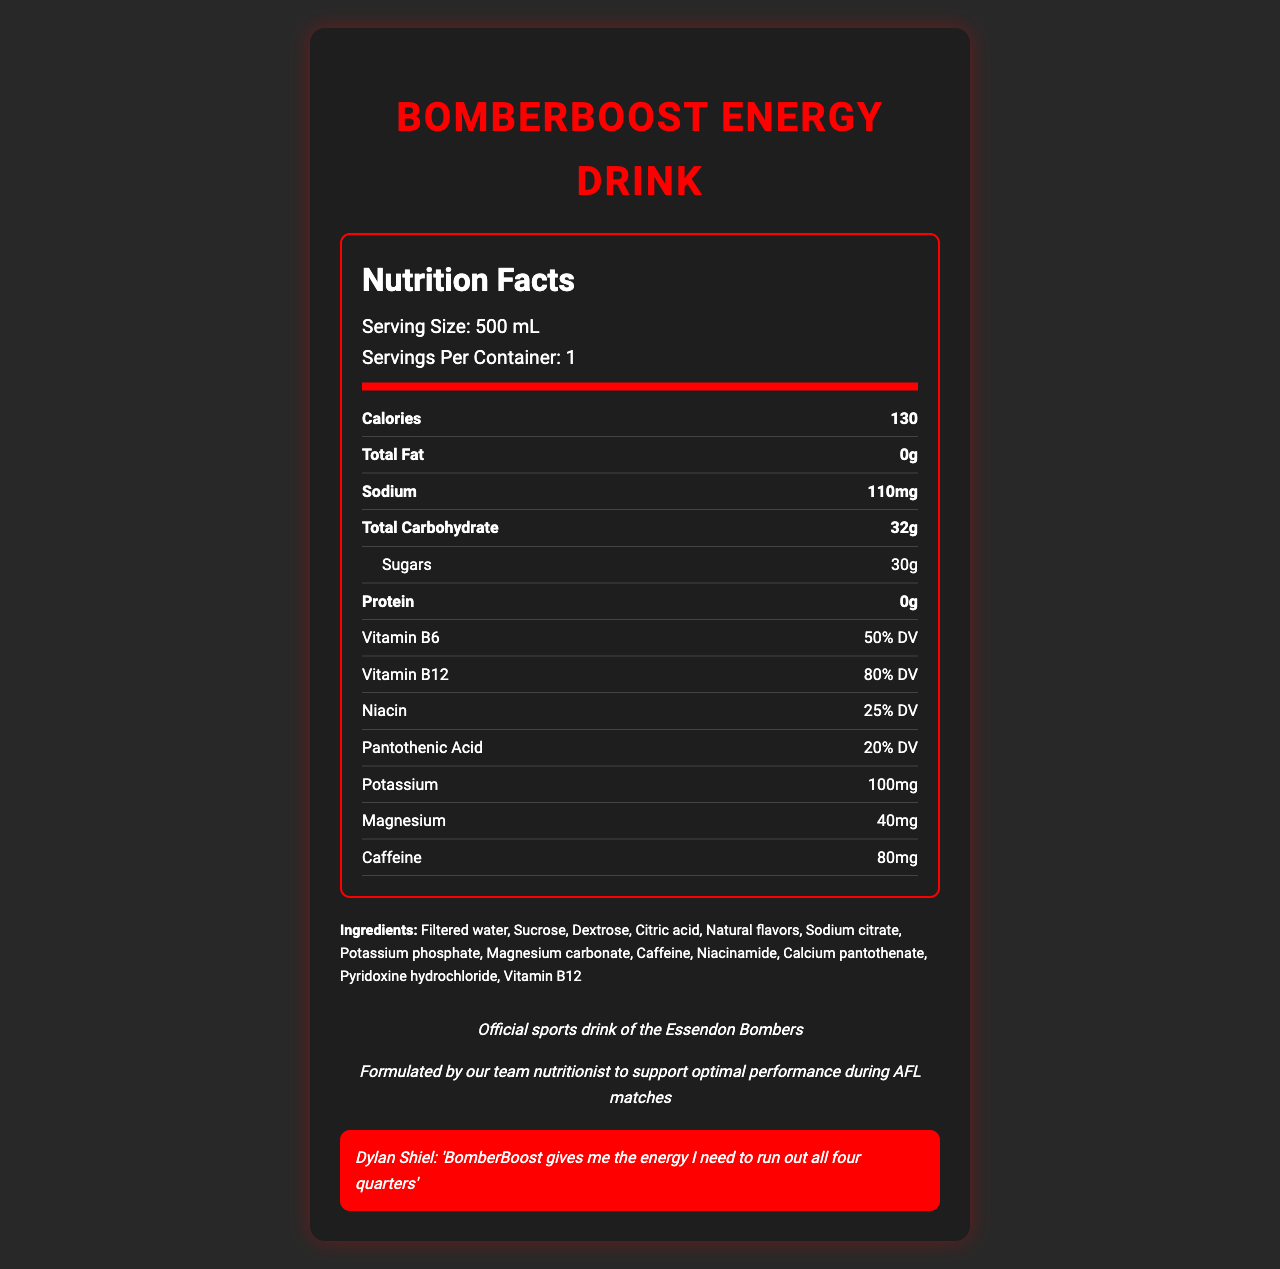what is the serving size of BomberBoost Energy Drink? The serving size is explicitly mentioned in the document under the nutrition facts.
Answer: 500 mL how many calories are in one serving of BomberBoost Energy Drink? The calories per serving are listed in the nutrition facts section as 130.
Answer: 130 how much caffeine is in BomberBoost Energy Drink? The amount of caffeine is listed under the nutrition facts section as 80mg.
Answer: 80mg which player from Essendon Football Club provided a testimonial for this drink? The testimonial by Dylan Shiel is quoted in the testimonial section of the document.
Answer: Dylan Shiel what is the percentage Daily Value (% DV) of Vitamin B12 in BomberBoost Energy Drink? The percentage Daily Value of Vitamin B12 is specified as 80% DV in the nutrition facts section.
Answer: 80% DV which of the following vitamins does BomberBoost Energy Drink contain the most of by percentage Daily Value (% DV)? A. Vitamin B6 B. Niacin C. Pantothenic Acid D. Vitamin B12 The document lists Vitamin B12 at 80% DV, which is the highest compared to Vitamin B6 at 50% DV, Niacin at 25% DV, and Pantothenic Acid at 20% DV.
Answer: D. Vitamin B12 what should you do with BomberBoost Energy Drink after opening it? A. Store at room temperature B. Refrigerate it C. Discard it D. Freeze it The storage instructions in the document state to "Refrigerate after opening."
Answer: B. Refrigerate it is BomberBoost Energy Drink produced exclusively for Essendon Football Club players? (Yes/No) The distribution section indicates that the drink is distributed exclusively for Essendon Football Club players.
Answer: Yes summarize the main idea of the document. The document provides detailed nutrition facts, ingredients, and endorsements, along with storage instructions and player testimonials, highlighting its athletic performance benefits.
Answer: BomberBoost Energy Drink is a sports drink designed and endorsed by the Essendon Football Club to enhance player performance with specific nutrients and vitamins. what is the price of BomberBoost Energy Drink? The document does not provide any information regarding the price of BomberBoost Energy Drink.
Answer: Not enough information 